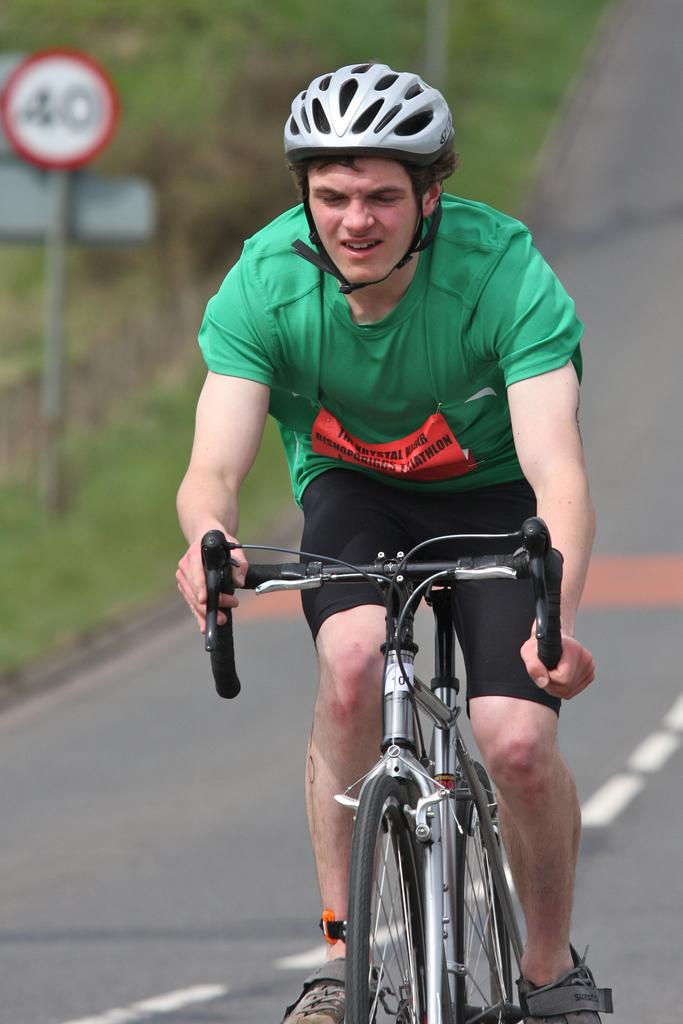What is the man in the image doing? The man is riding a bicycle in the image. What safety precaution is the man taking while riding the bicycle? The man is wearing a helmet. What color is the t-shirt the man is wearing? The man is wearing a green t-shirt. What type of vegetation can be seen in the image? There are trees visible in the image. What structure is present with a sign board in the image? There is a pole with a sign board in the image. Reasoning: Absurd Question/Answer: What type of riddle is written on the paper held by the man in the image? There is no paper held by the man in the image, and therefore no riddle can be observed. What type of nail is being used by the man to fix the bicycle in the image? There is no indication that the man is fixing the bicycle or using a nail in the image. 